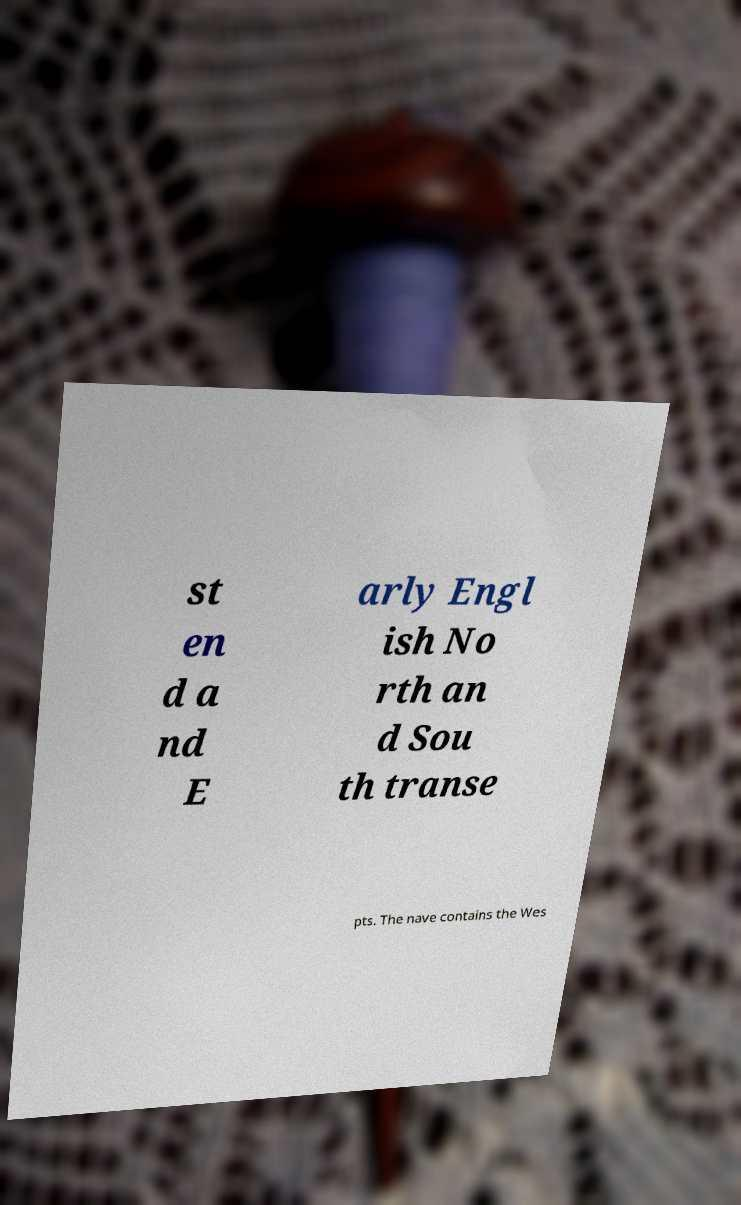What messages or text are displayed in this image? I need them in a readable, typed format. st en d a nd E arly Engl ish No rth an d Sou th transe pts. The nave contains the Wes 